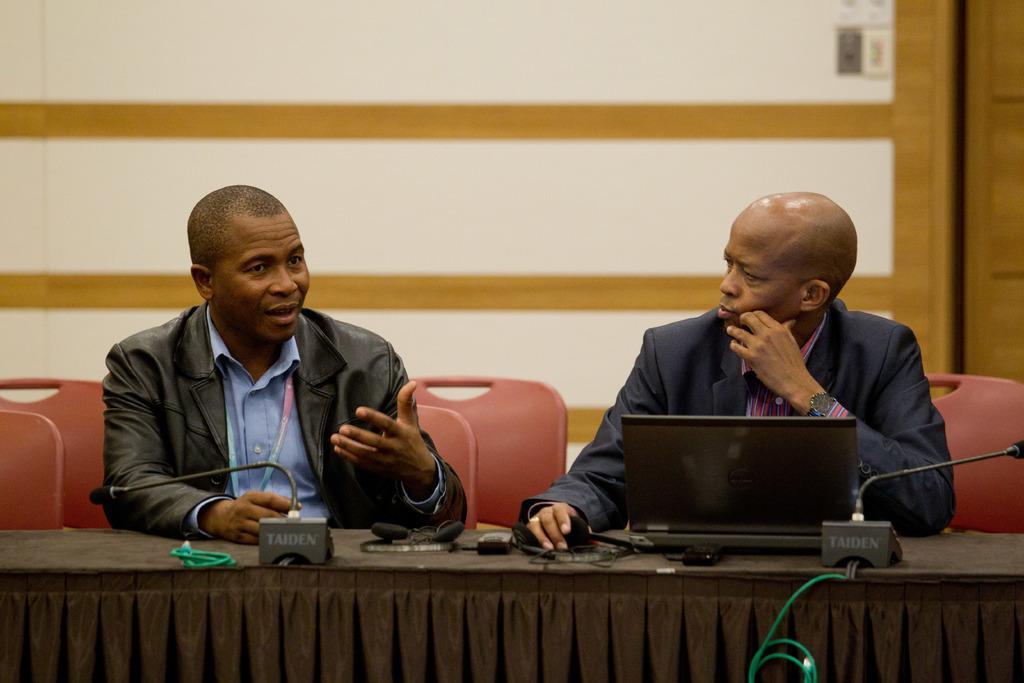Please provide a concise description of this image. As we can see in the image in the front there are two people wearing black color jacket and sitting on chairs. In front of them there is a table. On table there are mics, laptop and wires. 